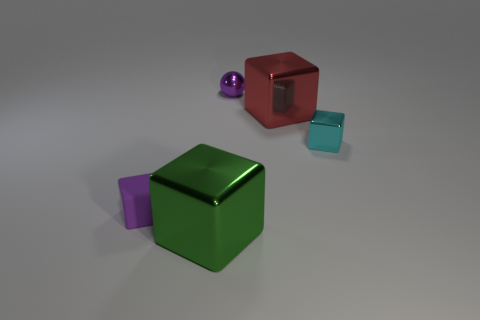What materials are the objects made of in this image? The objects in the image appear to have different materials. The big green and the small purple block look like they have matte finishes, suggesting a plastic or painted wood material. The red cube, due to its reflective property, might be made of a glossy painted metal. The small cyan block seems to be translucent, indicating a glass or acrylic material, while the ball has a metallic sheen to it. 